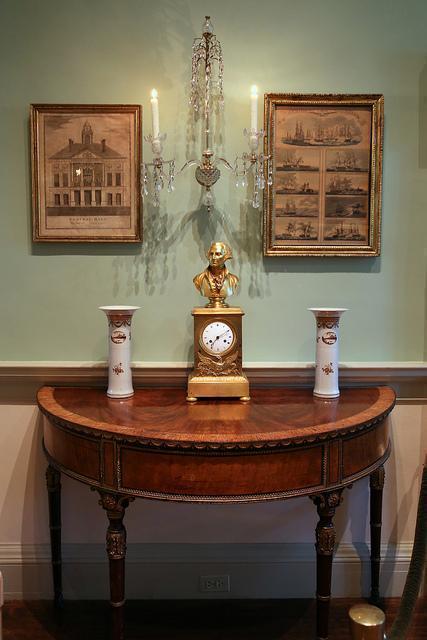How many items on the table are to the left of the clock?
Make your selection from the four choices given to correctly answer the question.
Options: Five, one, three, four. One. 